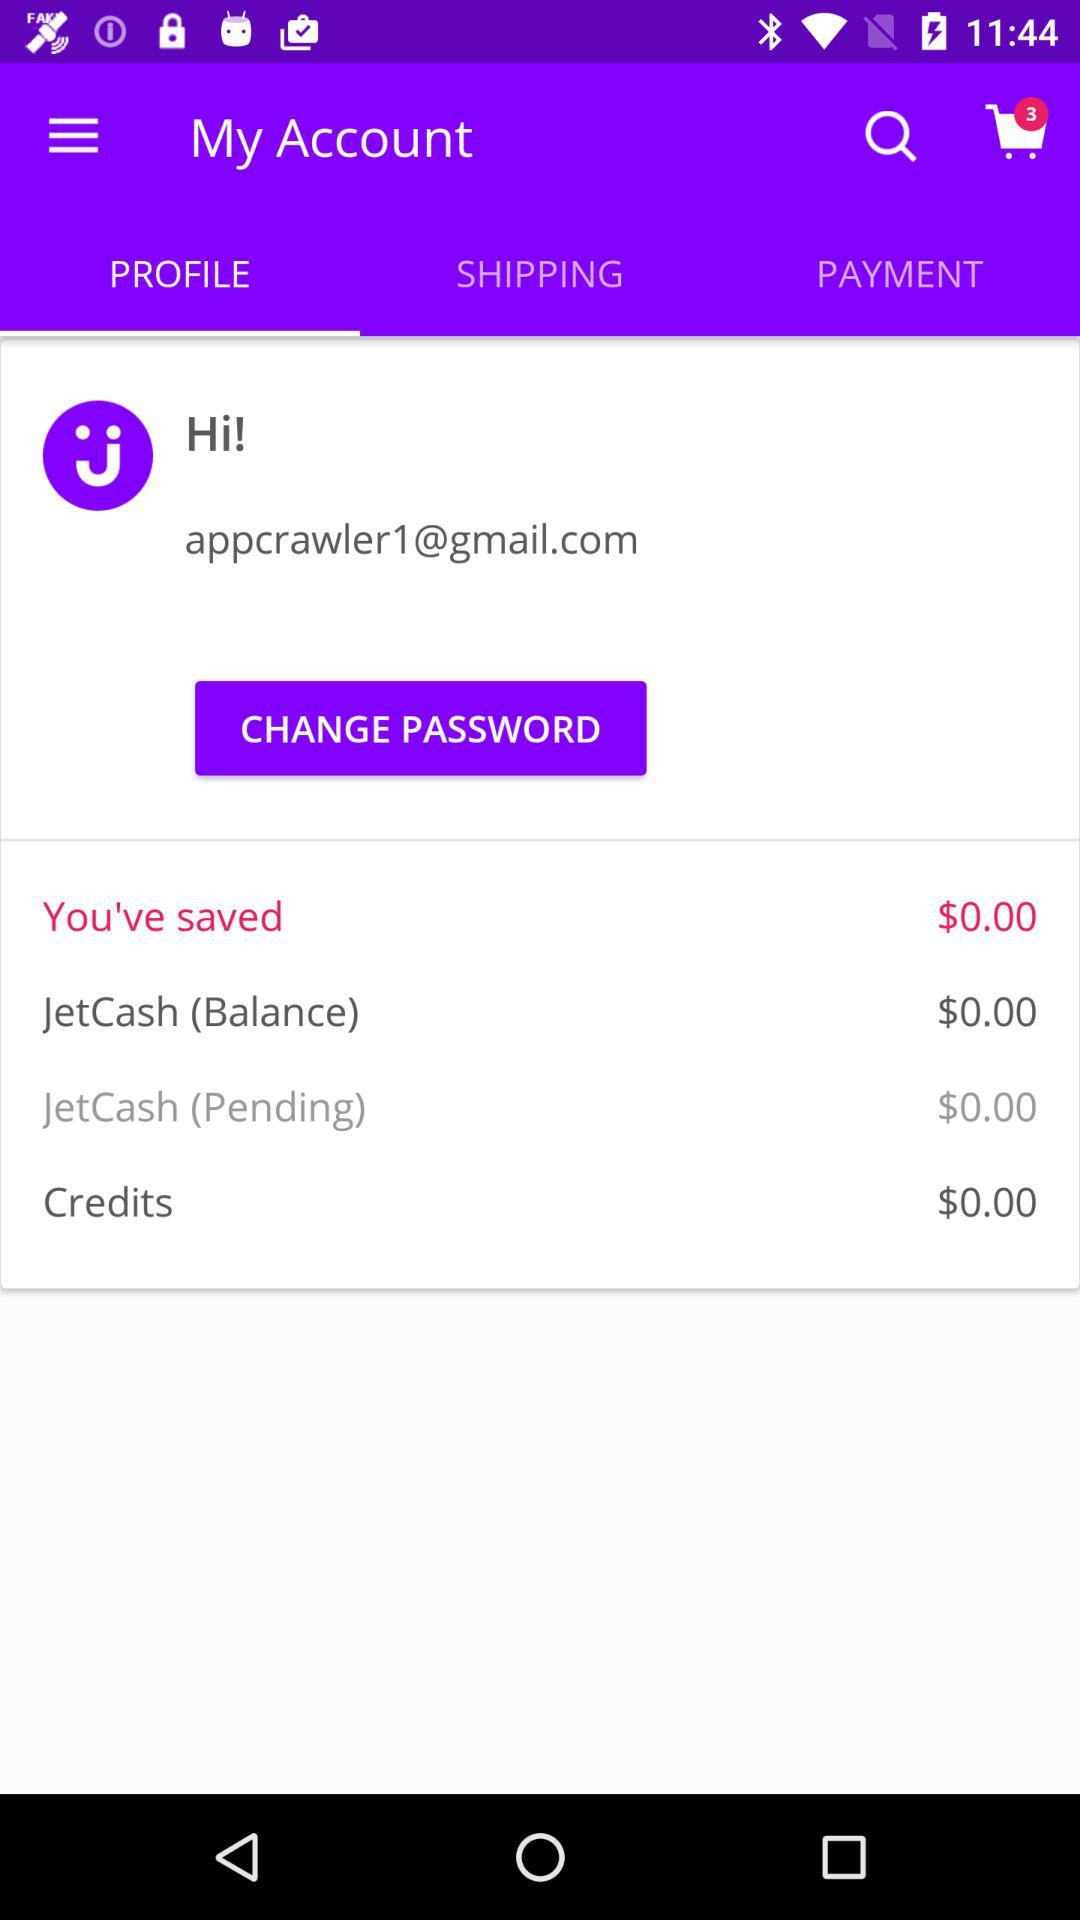How much is the "JetCash" balance? The "JetCash" balance is $0. 